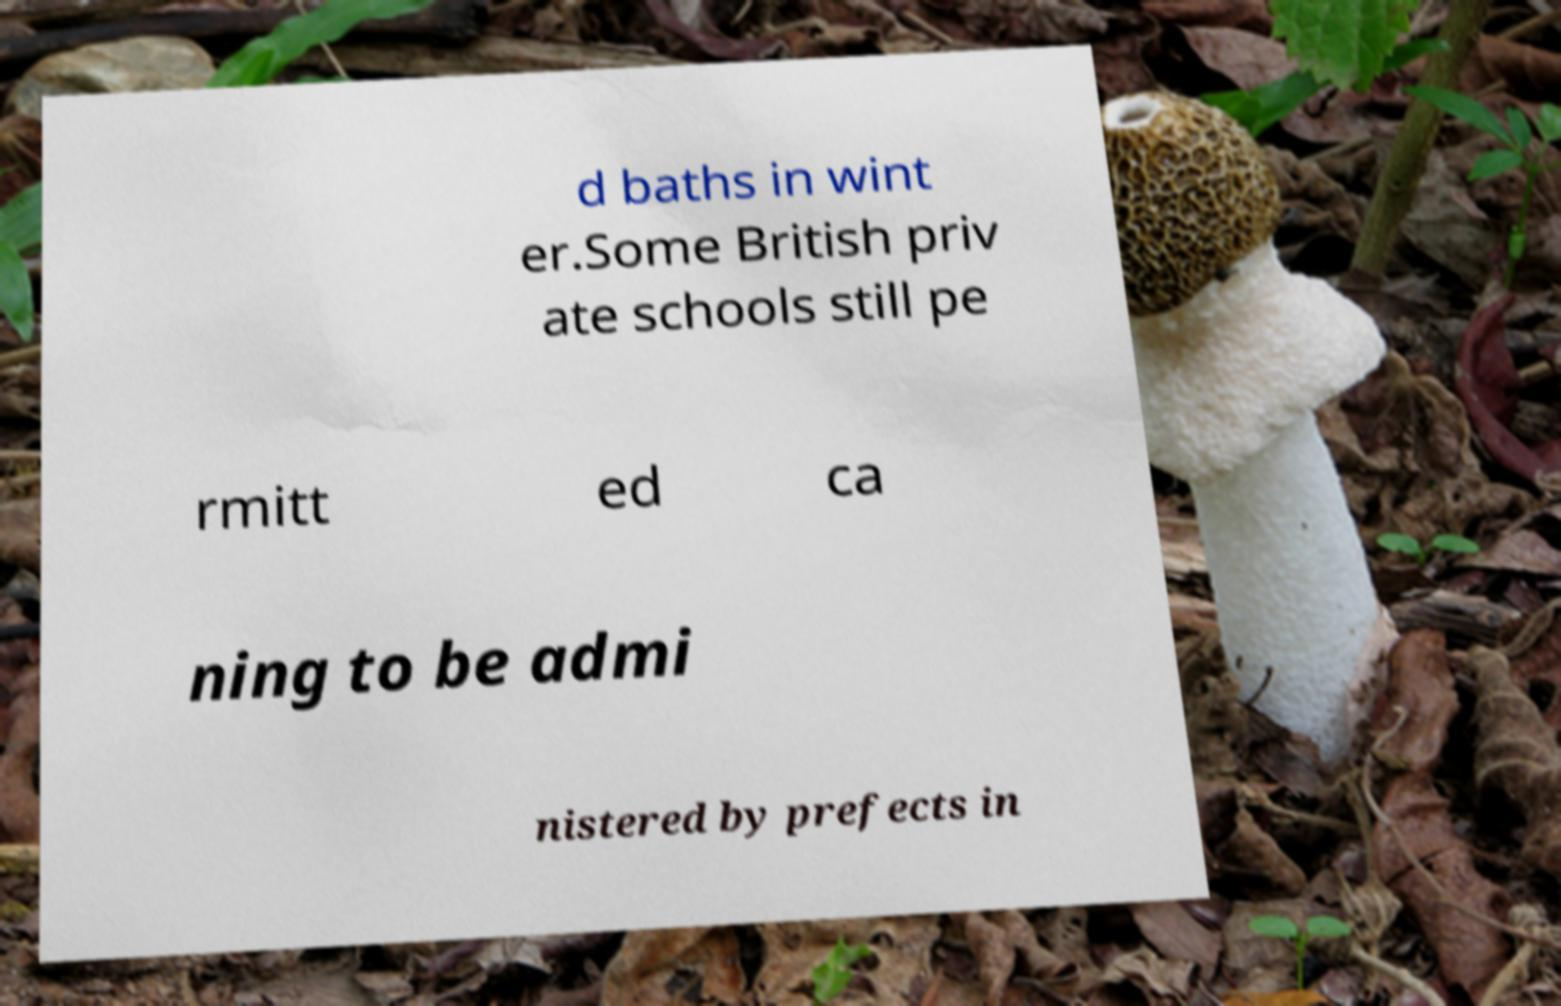Can you accurately transcribe the text from the provided image for me? d baths in wint er.Some British priv ate schools still pe rmitt ed ca ning to be admi nistered by prefects in 